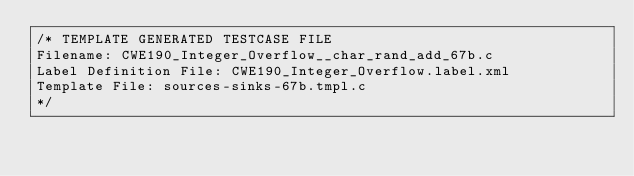Convert code to text. <code><loc_0><loc_0><loc_500><loc_500><_C_>/* TEMPLATE GENERATED TESTCASE FILE
Filename: CWE190_Integer_Overflow__char_rand_add_67b.c
Label Definition File: CWE190_Integer_Overflow.label.xml
Template File: sources-sinks-67b.tmpl.c
*/</code> 